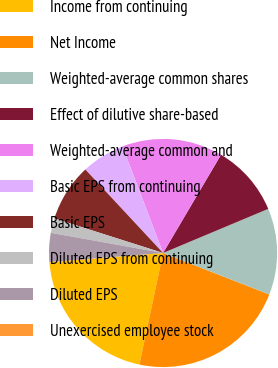<chart> <loc_0><loc_0><loc_500><loc_500><pie_chart><fcel>Income from continuing<fcel>Net Income<fcel>Weighted-average common shares<fcel>Effect of dilutive share-based<fcel>Weighted-average common and<fcel>Basic EPS from continuing<fcel>Basic EPS<fcel>Diluted EPS from continuing<fcel>Diluted EPS<fcel>Unexercised employee stock<nl><fcel>20.37%<fcel>22.41%<fcel>12.24%<fcel>10.2%<fcel>14.27%<fcel>6.14%<fcel>8.17%<fcel>2.07%<fcel>4.1%<fcel>0.03%<nl></chart> 